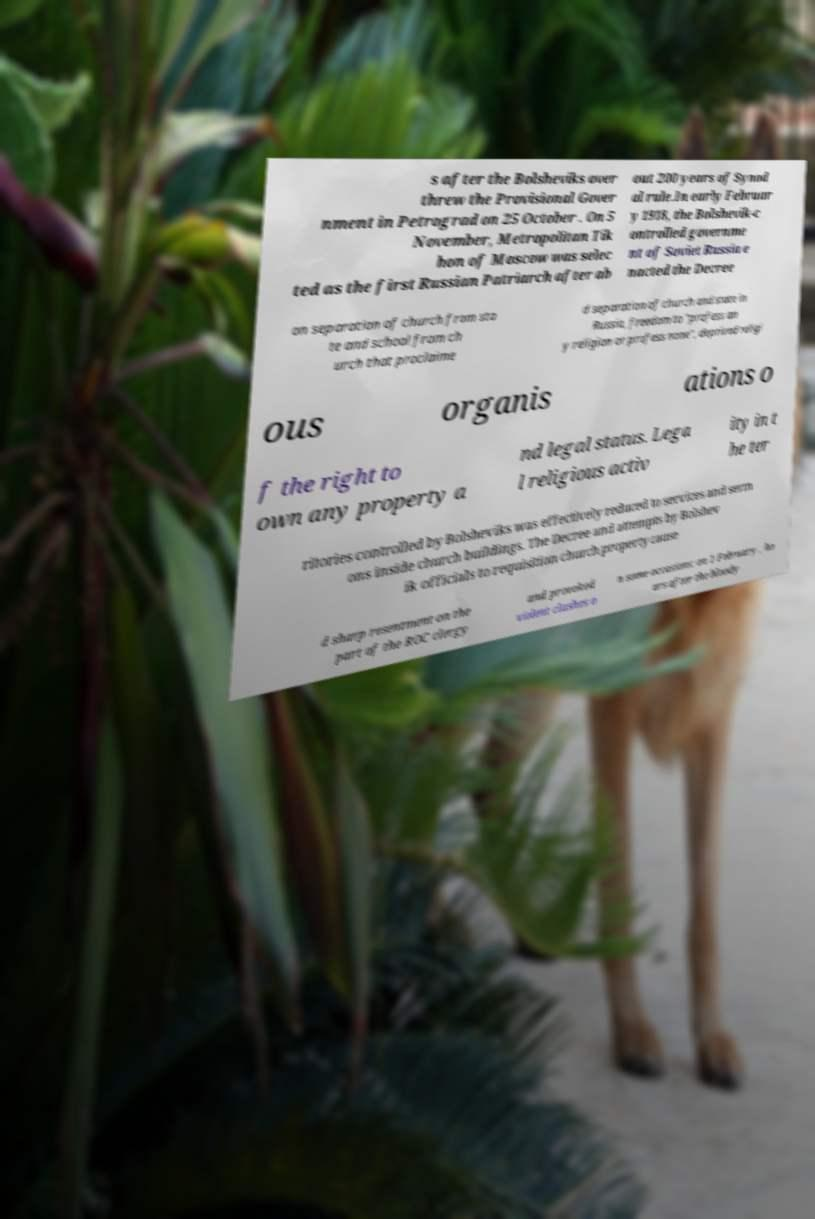For documentation purposes, I need the text within this image transcribed. Could you provide that? s after the Bolsheviks over threw the Provisional Gover nment in Petrograd on 25 October . On 5 November, Metropolitan Tik hon of Moscow was selec ted as the first Russian Patriarch after ab out 200 years of Synod al rule.In early Februar y 1918, the Bolshevik-c ontrolled governme nt of Soviet Russia e nacted the Decree on separation of church from sta te and school from ch urch that proclaime d separation of church and state in Russia, freedom to "profess an y religion or profess none", deprived religi ous organis ations o f the right to own any property a nd legal status. Lega l religious activ ity in t he ter ritories controlled by Bolsheviks was effectively reduced to services and serm ons inside church buildings. The Decree and attempts by Bolshev ik officials to requisition church property cause d sharp resentment on the part of the ROC clergy and provoked violent clashes o n some occasions: on 1 February , ho urs after the bloody 